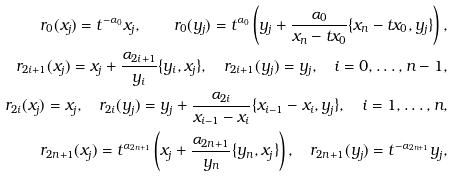<formula> <loc_0><loc_0><loc_500><loc_500>r _ { 0 } ( x _ { j } ) = t ^ { - \alpha _ { 0 } } x _ { j } , \quad r _ { 0 } ( y _ { j } ) = t ^ { \alpha _ { 0 } } \left ( y _ { j } + \frac { \alpha _ { 0 } } { x _ { n } - t x _ { 0 } } \{ x _ { n } - t x _ { 0 } , y _ { j } \} \right ) , \\ r _ { 2 i + 1 } ( x _ { j } ) = x _ { j } + \frac { \alpha _ { 2 i + 1 } } { y _ { i } } \{ y _ { i } , x _ { j } \} , \quad r _ { 2 i + 1 } ( y _ { j } ) = y _ { j } , \quad i = 0 , \dots , n - 1 , \\ r _ { 2 i } ( x _ { j } ) = x _ { j } , \quad r _ { 2 i } ( y _ { j } ) = y _ { j } + \frac { \alpha _ { 2 i } } { x _ { i - 1 } - x _ { i } } \{ x _ { i - 1 } - x _ { i } , y _ { j } \} , \quad i = 1 , \dots , n , \\ r _ { 2 n + 1 } ( x _ { j } ) = t ^ { \alpha _ { 2 n + 1 } } \left ( x _ { j } + \frac { \alpha _ { 2 n + 1 } } { y _ { n } } \{ y _ { n } , x _ { j } \} \right ) , \quad r _ { 2 n + 1 } ( y _ { j } ) = t ^ { - \alpha _ { 2 n + 1 } } y _ { j } ,</formula> 